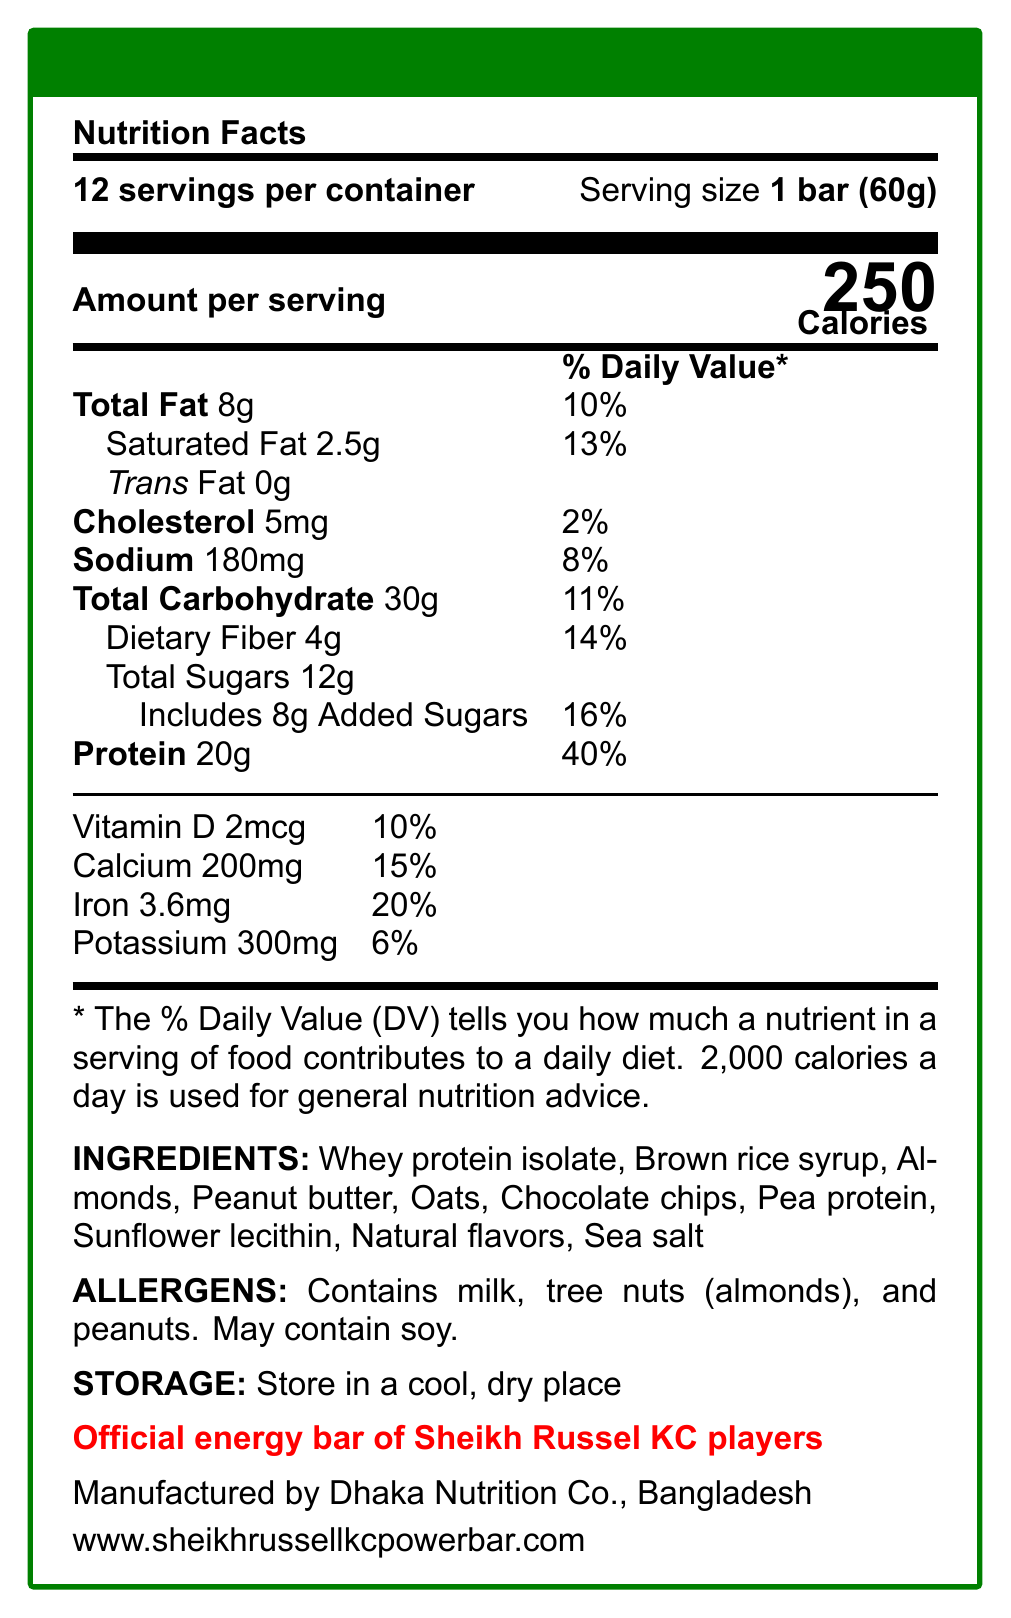what is the serving size of Sheikh Russel KC Power Bar? The document specifies that the serving size of the Sheikh Russel KC Power Bar is 1 bar (60g).
Answer: 1 bar (60g) how many calories are in one serving of the Power Bar? The document states that there are 250 calories in one serving of the Power Bar.
Answer: 250 what is the total fat content in a serving of the Power Bar? According to the document, the total fat content in one serving of the Power Bar is 8g.
Answer: 8g how much protein does one serving provide? The document indicates that one serving of the Power Bar provides 20g of protein.
Answer: 20g what are the main ingredients in the Power Bar? The ingredients list from the document includes Whey protein isolate, Brown rice syrup, Almonds, Peanut butter, Oats, Chocolate chips, Pea protein, Sunflower lecithin, Natural flavors, and Sea salt.
Answer: Whey protein isolate, Brown rice syrup, Almonds, Peanut butter, Oats, Chocolate chips, Pea protein, Sunflower lecithin, Natural flavors, Sea salt how many servings are there per container? The document notes that there are 12 servings per container.
Answer: 12 which of the following is NOT an allergen mentioned in the document? A. Milk B. Almonds C. Wheat D. Peanuts The document lists milk, tree nuts (almonds), and peanuts as allergens but does not mention wheat.
Answer: C how much saturated fat is in one serving of the Power Bar? A. 1.5g B. 2g C. 2.5g D. 3g The document states that one serving of the Power Bar contains 2.5g of saturated fat.
Answer: C is the Power Bar endorsed by Sheikh Russel KC players? The document clearly mentions that it is the official energy bar of Sheikh Russel KC players.
Answer: Yes summarize the nutritional information and key details about the Sheikh Russel KC Power Bar. The document provides comprehensive nutritional information and key details about the Sheikh Russel KC Power Bar, including serving size, calories, macronutrient content, vitamins, and minerals. It also lists ingredients, allergens, storage instructions, and the endorsement by Sheikh Russel KC players.
Answer: The Sheikh Russel KC Power Bar is a protein-rich meal replacement bar with 250 calories per serving. Each bar weighs 60g, and there are 12 servings per container. It contains 8g of total fat, 2.5g of saturated fat, and no trans fats. There are 20g of protein, 30g of carbohydrates with 4g of dietary fiber, and 12g of total sugars, including 8g added sugars. The bar also provides 2mcg of Vitamin D, 200mg of calcium, 3.6mg of iron, and 300mg of potassium. The ingredients include Whey protein isolate, Brown rice syrup, Almonds, Peanut butter, Oats, Chocolate chips, Pea protein, Sunflower lecithin, Natural flavors, and Sea salt. It contains allergens such as milk, tree nuts (almonds), and peanuts, and may contain soy. It is endorsed by Sheikh Russel KC players and manufactured by Dhaka Nutrition Co., Bangladesh. who manufactures the Sheikh Russel KC Power Bar? The document states that the manufacturer is Dhaka Nutrition Co., Bangladesh.
Answer: Dhaka Nutrition Co., Bangladesh what percentage of the daily value for protein does the Power Bar provide in one serving? The document indicates that one serving of the Power Bar provides 40% of the daily value for protein.
Answer: 40% how much sodium is in a single serving? According to the document, there are 180mg of sodium in a single serving of the Power Bar.
Answer: 180mg is the Sheikh Russel KC Power Bar gluten-free? The document does not provide information about whether the Power Bar is gluten-free.
Answer: Not enough information what should be the storage condition for the Power Bar? The document advises storing the Power Bar in a cool, dry place.
Answer: Store in a cool, dry place 